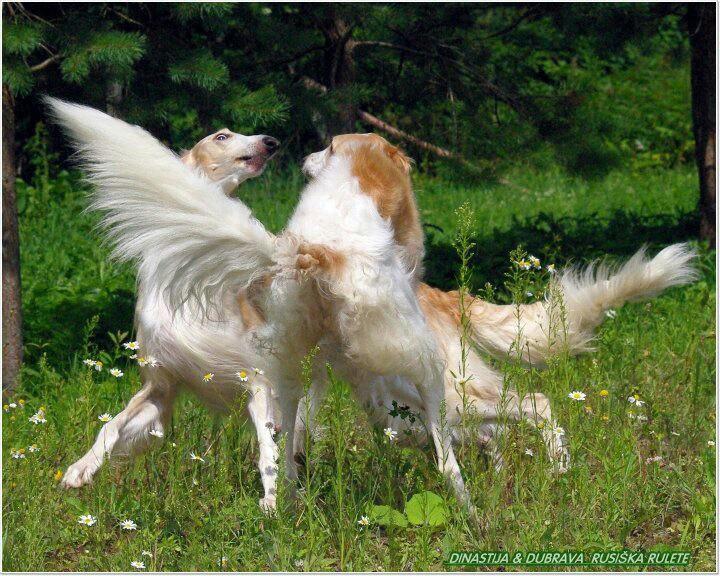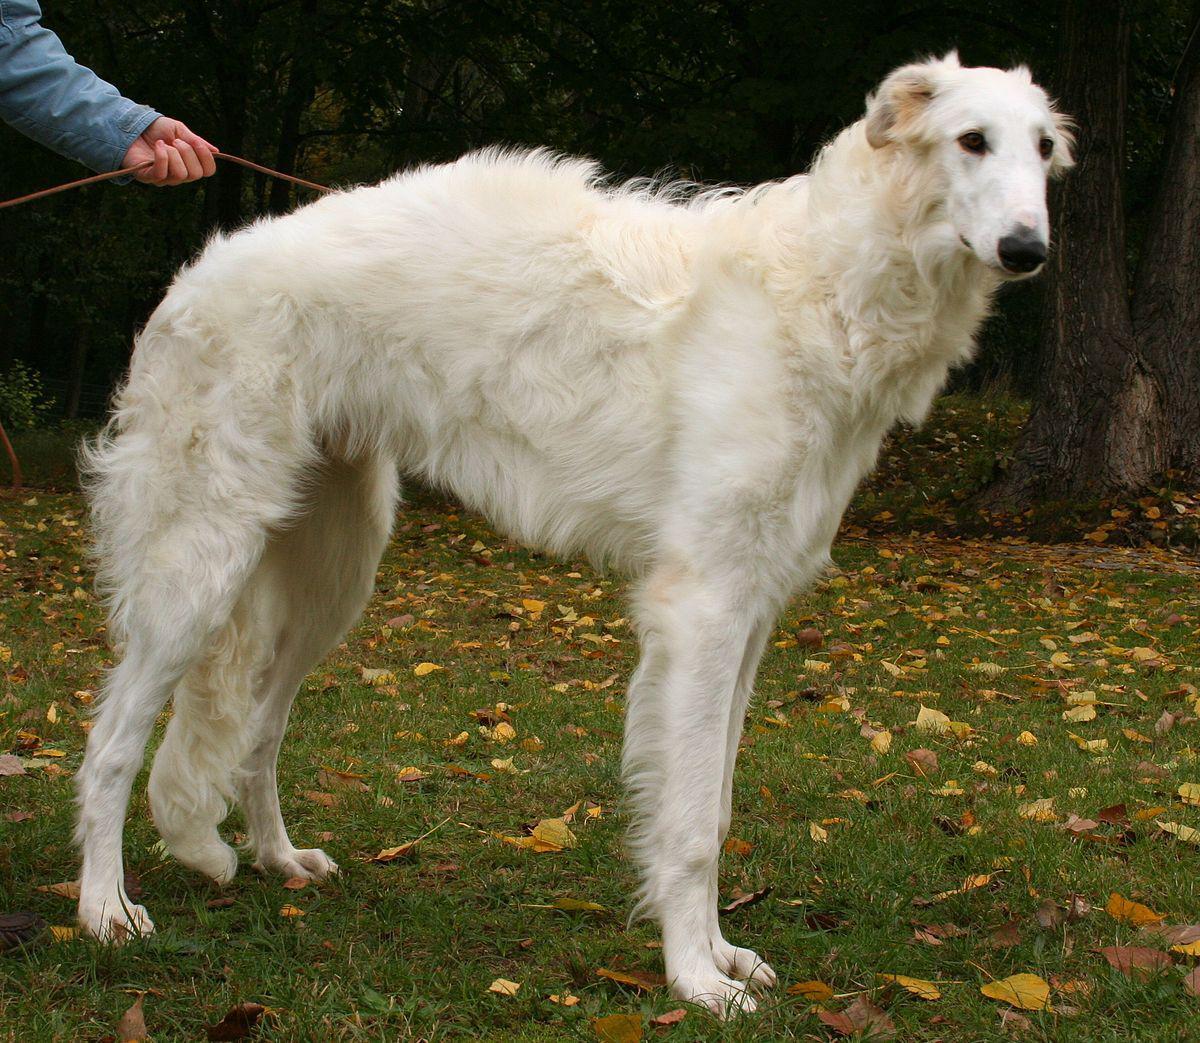The first image is the image on the left, the second image is the image on the right. For the images shown, is this caption "There are two women, and each has at least one dog." true? Answer yes or no. No. The first image is the image on the left, the second image is the image on the right. Examine the images to the left and right. Is the description "One of the photos shows two dogs and no people." accurate? Answer yes or no. Yes. 